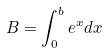<formula> <loc_0><loc_0><loc_500><loc_500>B = \int _ { 0 } ^ { b } e ^ { x } d x</formula> 